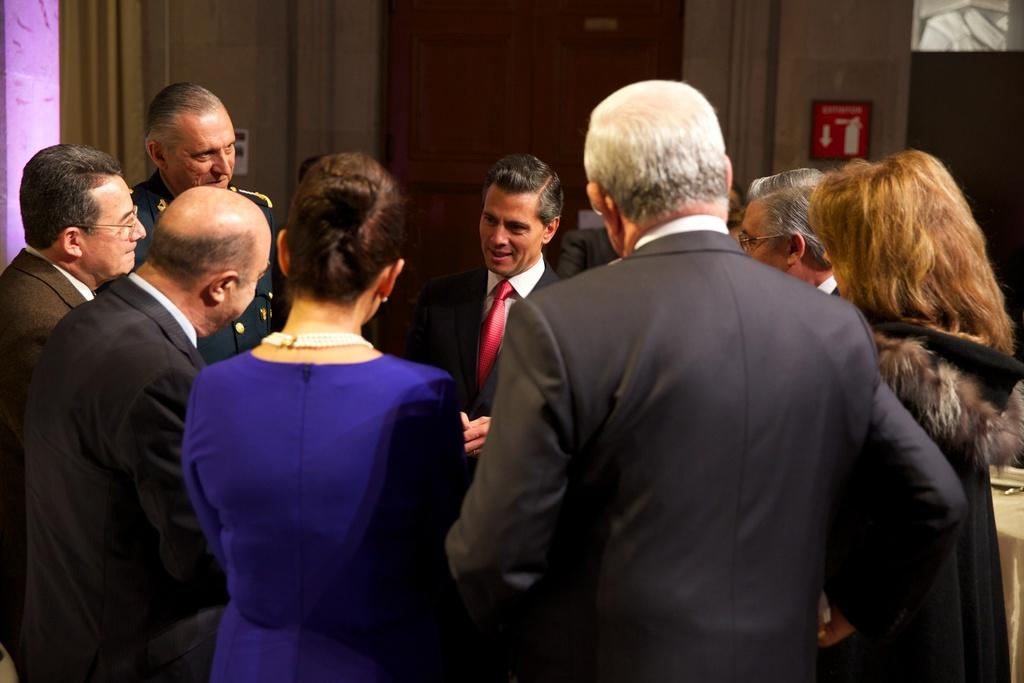What is the main focus of the image? There are people in the center of the image. What can be seen in the background of the image? There is a door and a wall in the background of the image. Where is the table located in the image? The table is to the right side of the image. What is on the table? There is a cloth on the table. Is there a water fountain in the image? There is no mention of a water fountain in the provided facts, so it cannot be determined if one is present in the image. 